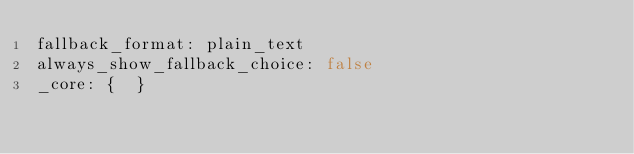Convert code to text. <code><loc_0><loc_0><loc_500><loc_500><_YAML_>fallback_format: plain_text
always_show_fallback_choice: false
_core: {  }
</code> 